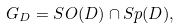<formula> <loc_0><loc_0><loc_500><loc_500>G _ { D } = S O ( D ) \cap S p ( D ) ,</formula> 